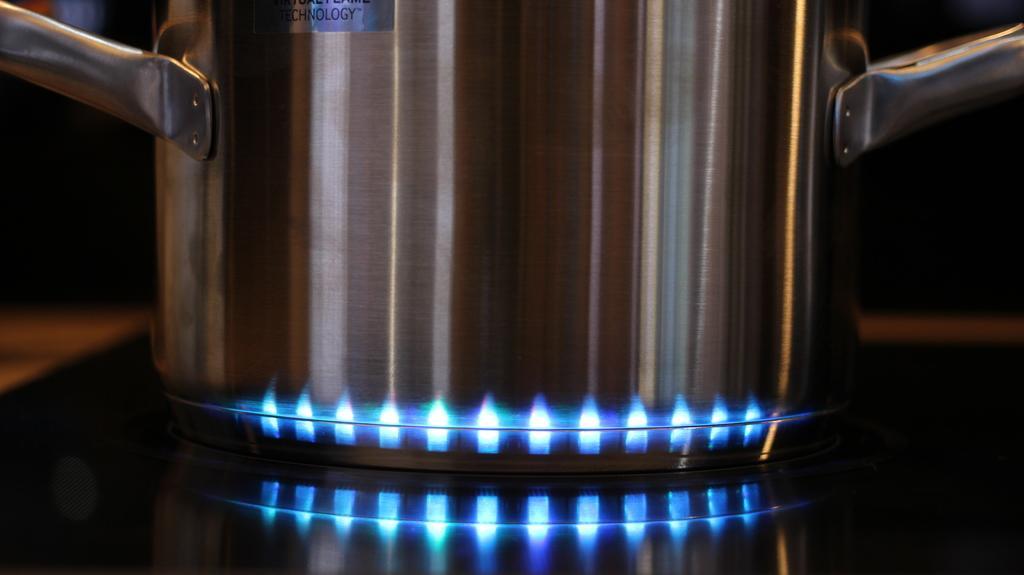Describe this image in one or two sentences. In this image we can see an utensil on the gas stove. 